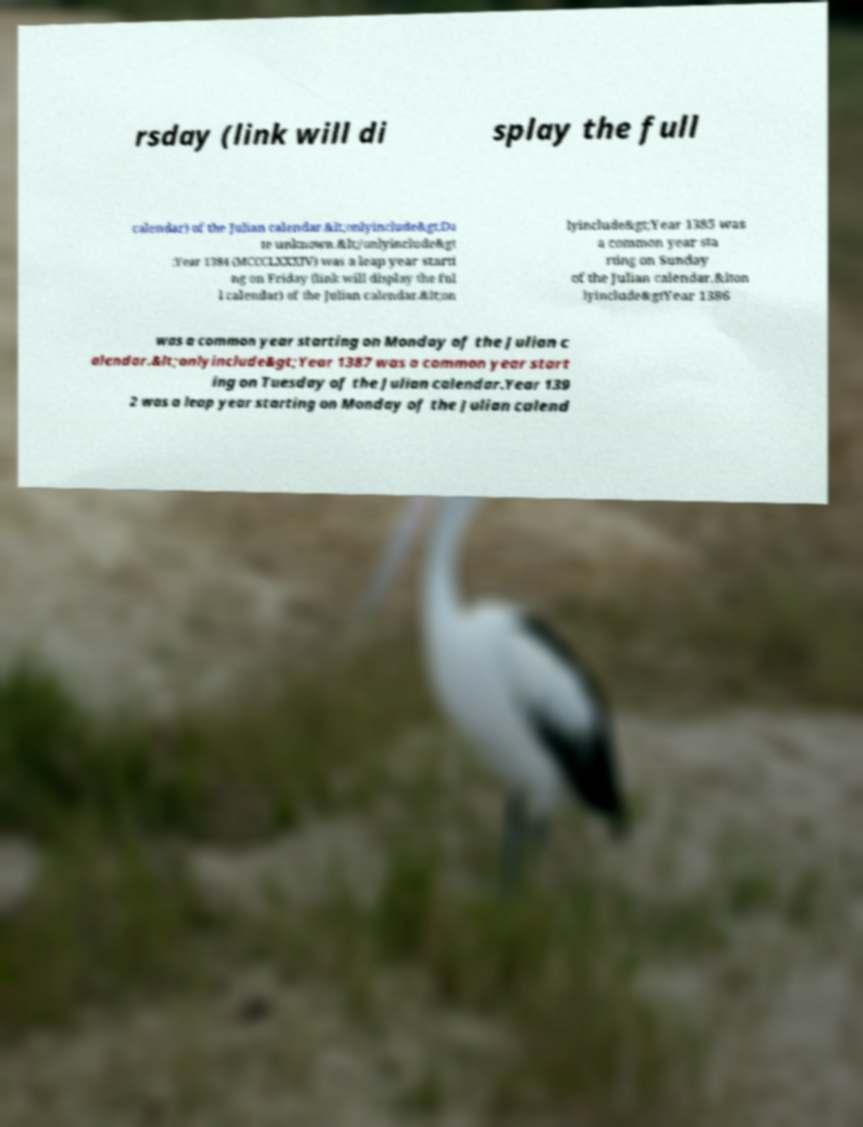Could you extract and type out the text from this image? rsday (link will di splay the full calendar) of the Julian calendar.&lt;onlyinclude&gt;Da te unknown.&lt;/onlyinclude&gt ;Year 1384 (MCCCLXXXIV) was a leap year starti ng on Friday (link will display the ful l calendar) of the Julian calendar.&lt;on lyinclude&gt;Year 1385 was a common year sta rting on Sunday of the Julian calendar.&lton lyinclude&gtYear 1386 was a common year starting on Monday of the Julian c alendar.&lt;onlyinclude&gt;Year 1387 was a common year start ing on Tuesday of the Julian calendar.Year 139 2 was a leap year starting on Monday of the Julian calend 